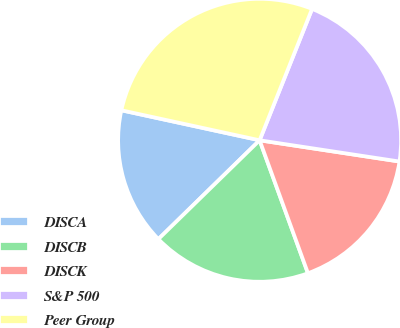Convert chart. <chart><loc_0><loc_0><loc_500><loc_500><pie_chart><fcel>DISCA<fcel>DISCB<fcel>DISCK<fcel>S&P 500<fcel>Peer Group<nl><fcel>15.71%<fcel>18.24%<fcel>17.05%<fcel>21.35%<fcel>27.64%<nl></chart> 